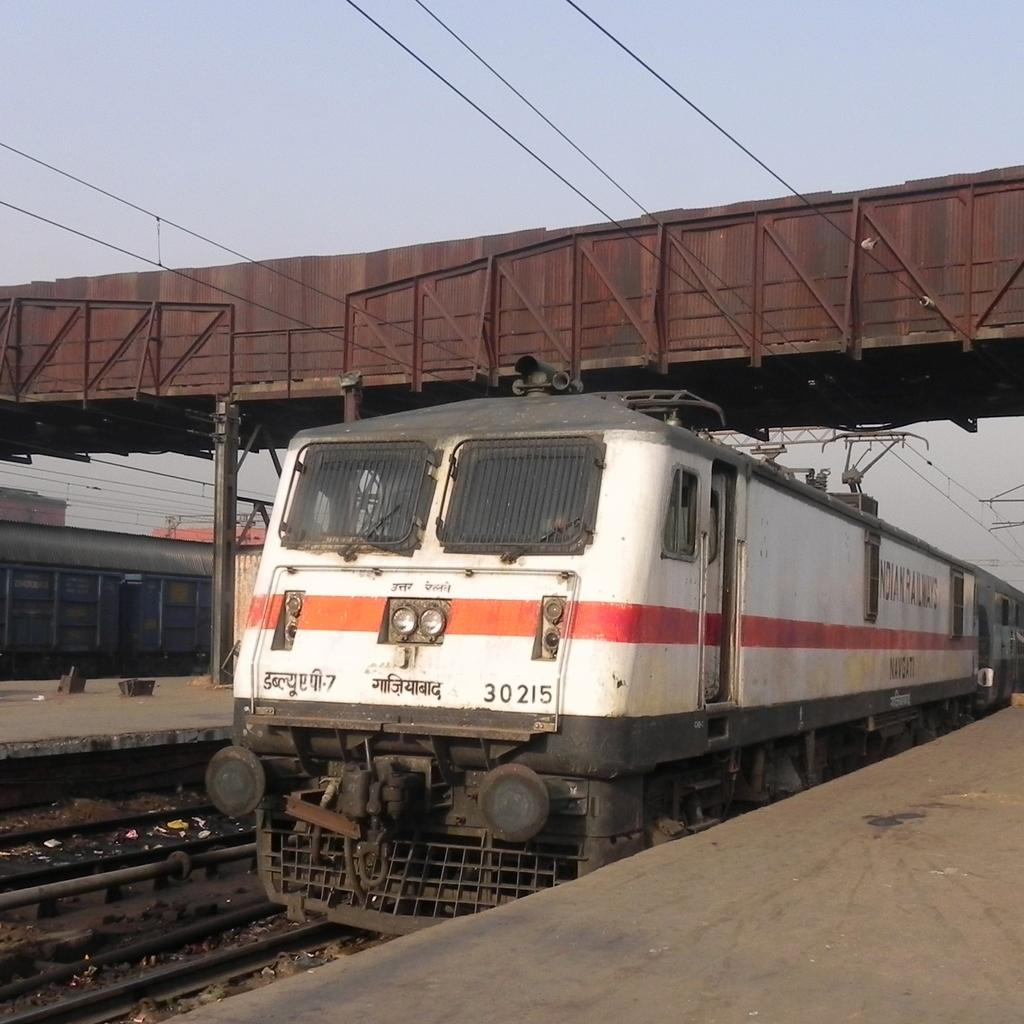<image>
Summarize the visual content of the image. Train number 30215 is shown on the tracks. 